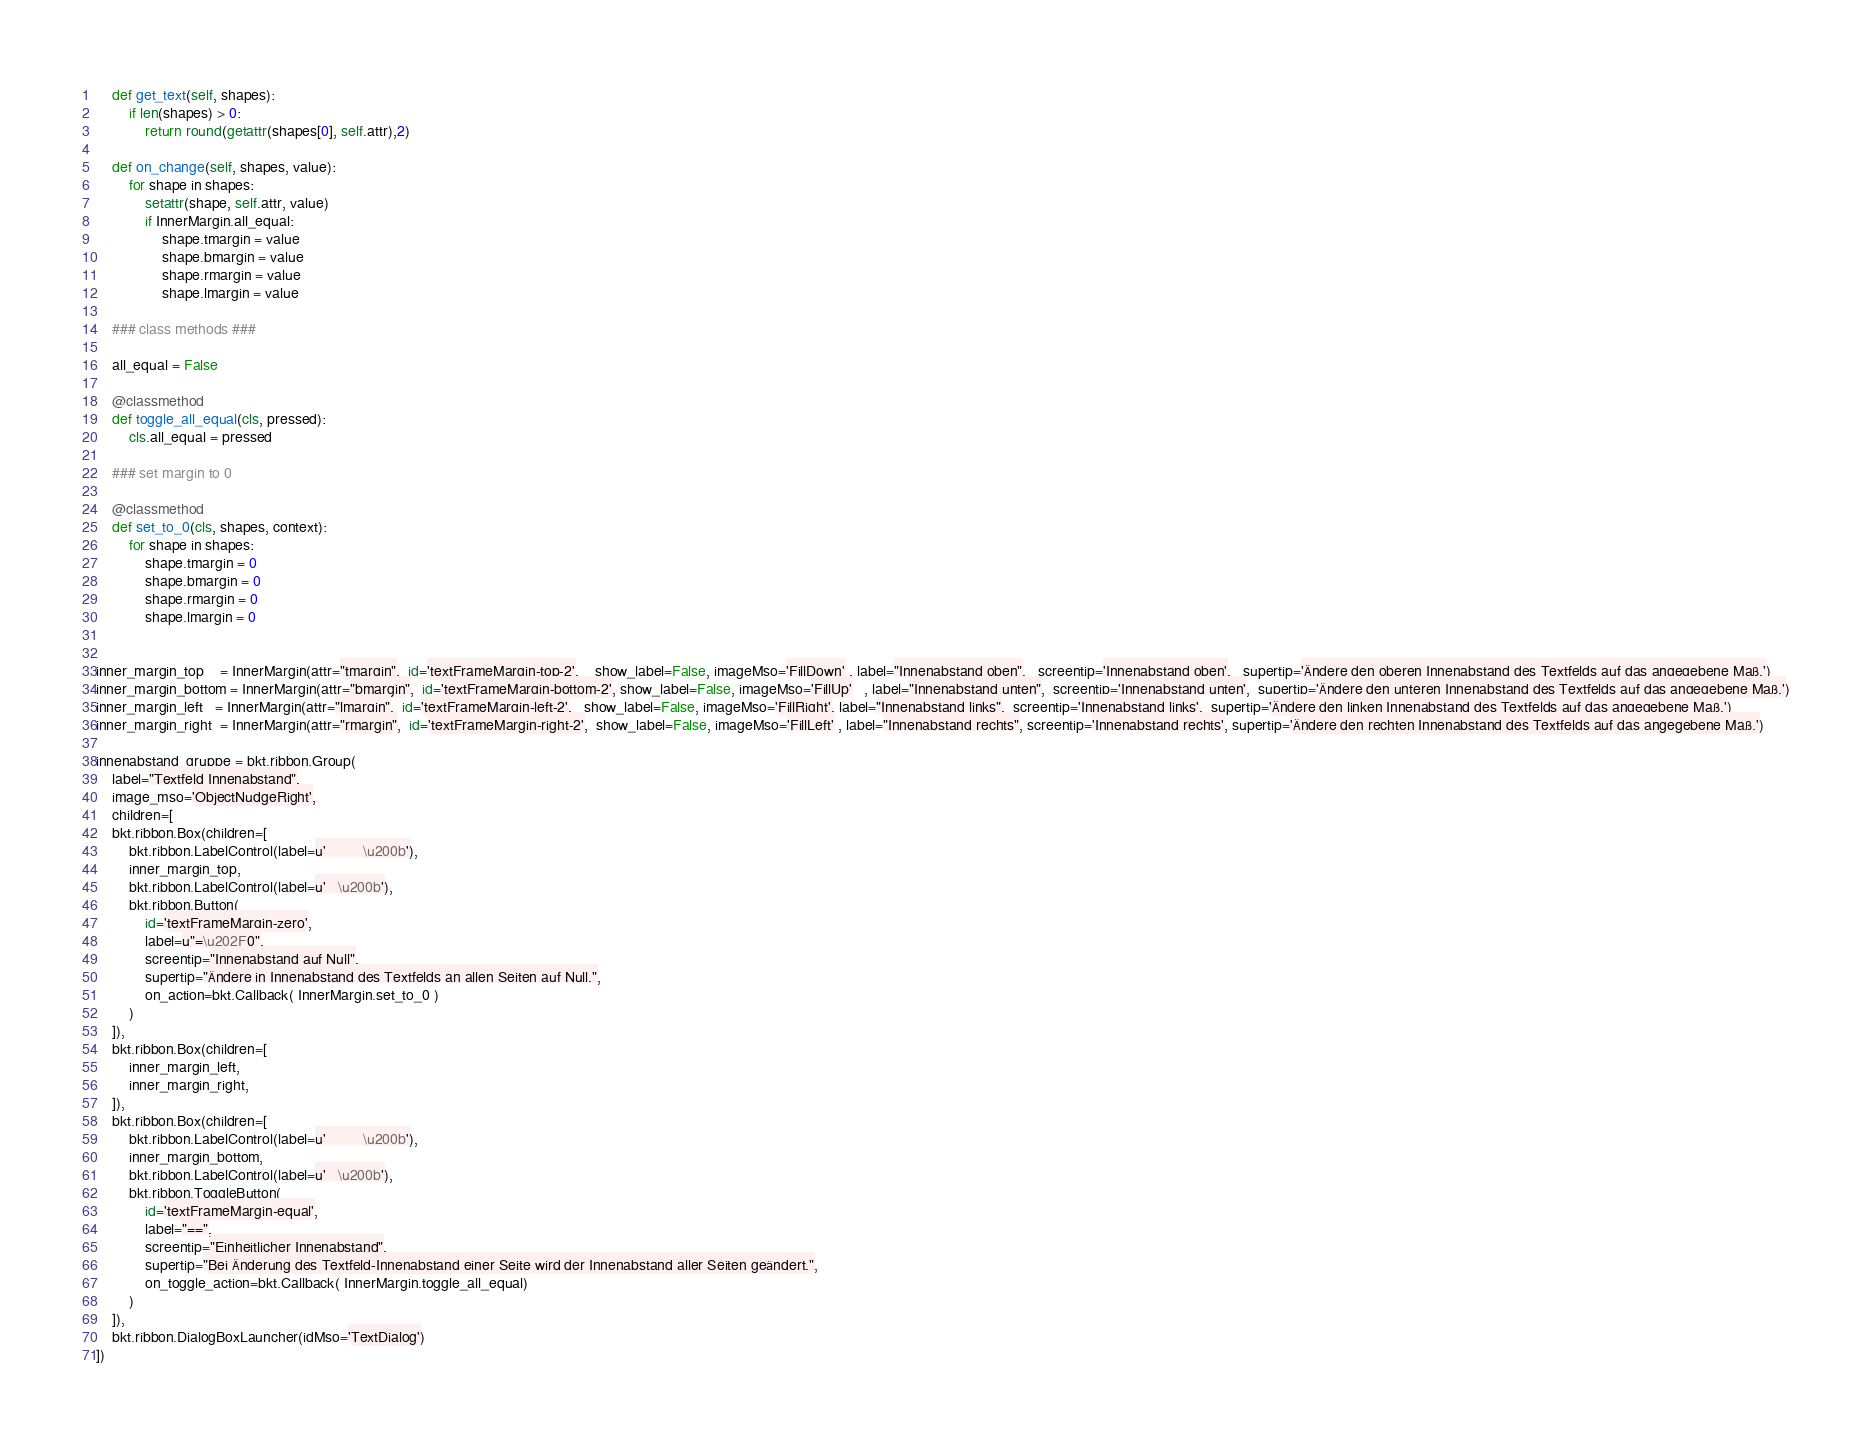Convert code to text. <code><loc_0><loc_0><loc_500><loc_500><_Python_>    def get_text(self, shapes):
        if len(shapes) > 0:
            return round(getattr(shapes[0], self.attr),2)
        
    def on_change(self, shapes, value):
        for shape in shapes:
            setattr(shape, self.attr, value)
            if InnerMargin.all_equal:
                shape.tmargin = value
                shape.bmargin = value
                shape.rmargin = value
                shape.lmargin = value
    
    ### class methods ###
    
    all_equal = False

    @classmethod
    def toggle_all_equal(cls, pressed):
        cls.all_equal = pressed
    
    ### set margin to 0
    
    @classmethod
    def set_to_0(cls, shapes, context):
        for shape in shapes:
            shape.tmargin = 0
            shape.bmargin = 0
            shape.rmargin = 0
            shape.lmargin = 0


inner_margin_top    = InnerMargin(attr="tmargin",  id='textFrameMargin-top-2',    show_label=False, imageMso='FillDown' , label="Innenabstand oben",   screentip='Innenabstand oben',   supertip='Ändere den oberen Innenabstand des Textfelds auf das angegebene Maß.')
inner_margin_bottom = InnerMargin(attr="bmargin",  id='textFrameMargin-bottom-2', show_label=False, imageMso='FillUp'   , label="Innenabstand unten",  screentip='Innenabstand unten',  supertip='Ändere den unteren Innenabstand des Textfelds auf das angegebene Maß.')
inner_margin_left   = InnerMargin(attr="lmargin",  id='textFrameMargin-left-2',   show_label=False, imageMso='FillRight', label="Innenabstand links",  screentip='Innenabstand links',  supertip='Ändere den linken Innenabstand des Textfelds auf das angegebene Maß.')
inner_margin_right  = InnerMargin(attr="rmargin",  id='textFrameMargin-right-2',  show_label=False, imageMso='FillLeft' , label="Innenabstand rechts", screentip='Innenabstand rechts', supertip='Ändere den rechten Innenabstand des Textfelds auf das angegebene Maß.')

innenabstand_gruppe = bkt.ribbon.Group(
    label="Textfeld Innenabstand",
    image_mso='ObjectNudgeRight',
    children=[
    bkt.ribbon.Box(children=[
        bkt.ribbon.LabelControl(label=u'         \u200b'),
        inner_margin_top,
        bkt.ribbon.LabelControl(label=u'   \u200b'),
        bkt.ribbon.Button(
            id='textFrameMargin-zero',
            label=u"=\u202F0",
            screentip="Innenabstand auf Null",
            supertip="Ändere in Innenabstand des Textfelds an allen Seiten auf Null.",
            on_action=bkt.Callback( InnerMargin.set_to_0 )
        )
    ]),
    bkt.ribbon.Box(children=[
        inner_margin_left,
        inner_margin_right,
    ]),
    bkt.ribbon.Box(children=[
        bkt.ribbon.LabelControl(label=u'         \u200b'),
        inner_margin_bottom,
        bkt.ribbon.LabelControl(label=u'   \u200b'),
        bkt.ribbon.ToggleButton(
            id='textFrameMargin-equal',
            label="==",
            screentip="Einheitlicher Innenabstand",
            supertip="Bei Änderung des Textfeld-Innenabstand einer Seite wird der Innenabstand aller Seiten geändert.",
            on_toggle_action=bkt.Callback( InnerMargin.toggle_all_equal)
        )
    ]),
    bkt.ribbon.DialogBoxLauncher(idMso='TextDialog')
])</code> 